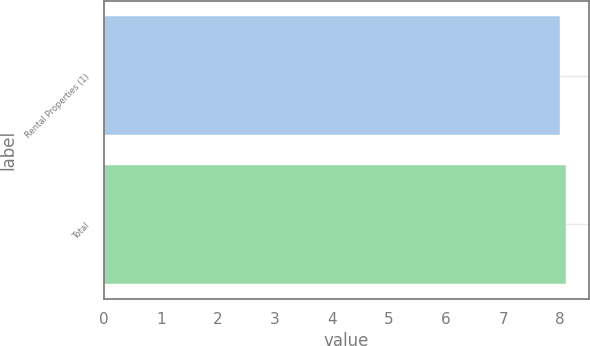Convert chart to OTSL. <chart><loc_0><loc_0><loc_500><loc_500><bar_chart><fcel>Rental Properties (1)<fcel>Total<nl><fcel>8<fcel>8.1<nl></chart> 